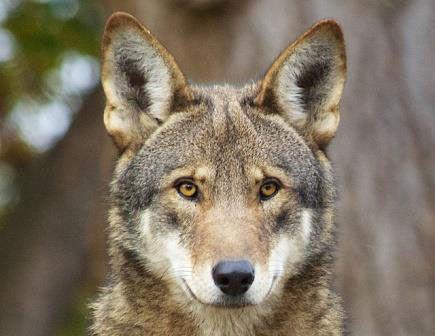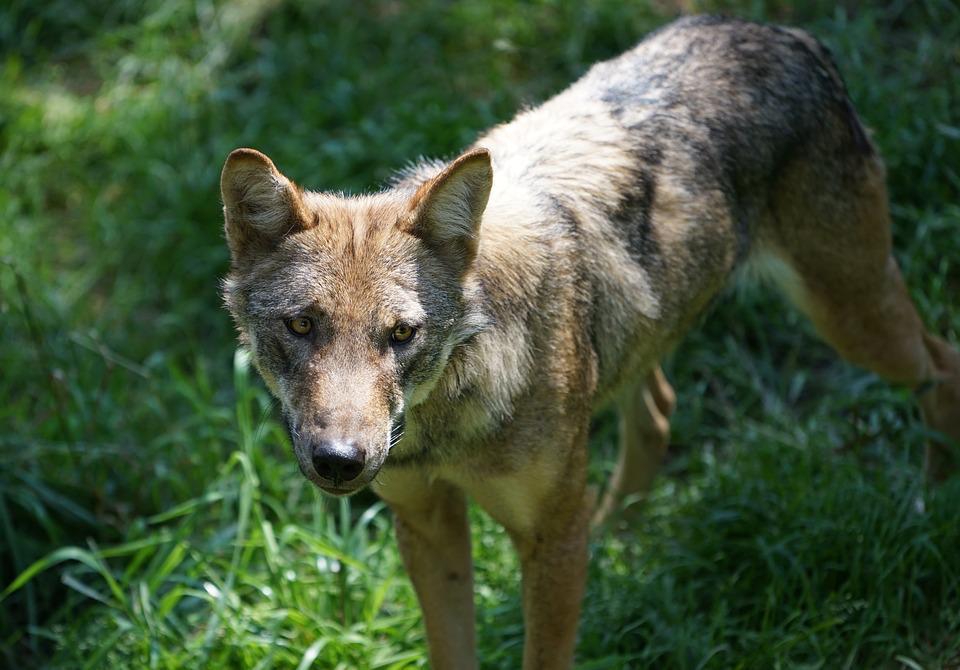The first image is the image on the left, the second image is the image on the right. Considering the images on both sides, is "At least one image shows a wold standing on all fours in a nonsnowy setting." valid? Answer yes or no. Yes. The first image is the image on the left, the second image is the image on the right. Evaluate the accuracy of this statement regarding the images: "A wolfs tongue is visible.". Is it true? Answer yes or no. No. 